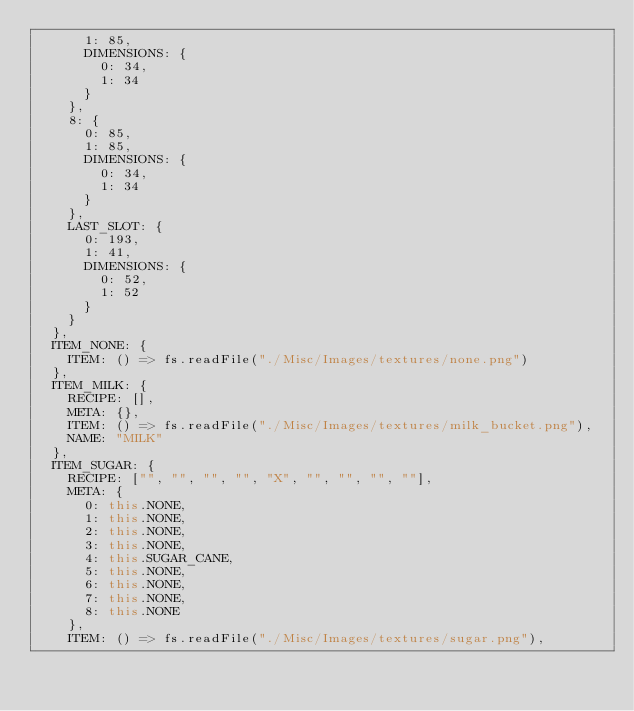Convert code to text. <code><loc_0><loc_0><loc_500><loc_500><_JavaScript_>      1: 85,
      DIMENSIONS: {
        0: 34,
        1: 34
      }
    },
    8: {
      0: 85,
      1: 85,
      DIMENSIONS: {
        0: 34,
        1: 34
      }
    },
    LAST_SLOT: {
      0: 193,
      1: 41,
      DIMENSIONS: {
        0: 52,
        1: 52
      }
    }
  },
  ITEM_NONE: {
    ITEM: () => fs.readFile("./Misc/Images/textures/none.png")
  },
  ITEM_MILK: {
    RECIPE: [],
    META: {},
    ITEM: () => fs.readFile("./Misc/Images/textures/milk_bucket.png"),
    NAME: "MILK"
  },
  ITEM_SUGAR: {
    RECIPE: ["", "", "", "", "X", "", "", "", ""],
    META: {
      0: this.NONE,
      1: this.NONE,
      2: this.NONE,
      3: this.NONE,
      4: this.SUGAR_CANE,
      5: this.NONE,
      6: this.NONE,
      7: this.NONE,
      8: this.NONE
    },
    ITEM: () => fs.readFile("./Misc/Images/textures/sugar.png"),</code> 